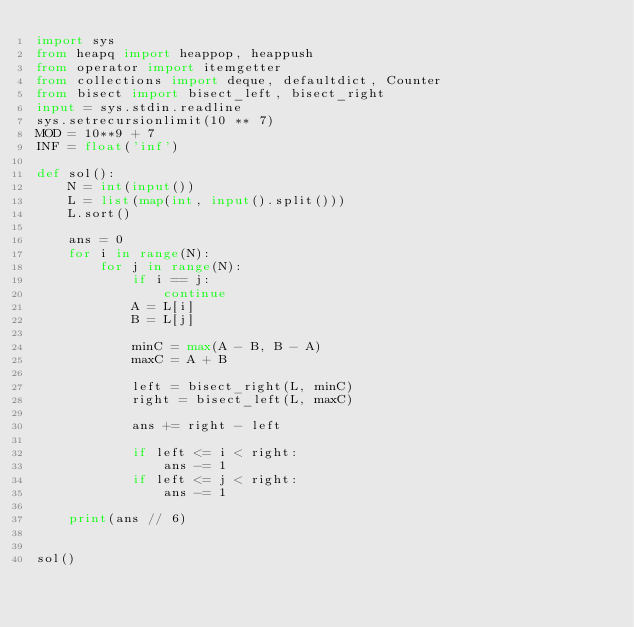<code> <loc_0><loc_0><loc_500><loc_500><_Python_>import sys
from heapq import heappop, heappush
from operator import itemgetter
from collections import deque, defaultdict, Counter
from bisect import bisect_left, bisect_right
input = sys.stdin.readline
sys.setrecursionlimit(10 ** 7)
MOD = 10**9 + 7
INF = float('inf')

def sol():
    N = int(input())
    L = list(map(int, input().split()))
    L.sort()

    ans = 0
    for i in range(N):
        for j in range(N):
            if i == j:
                continue
            A = L[i]
            B = L[j]

            minC = max(A - B, B - A)
            maxC = A + B

            left = bisect_right(L, minC)
            right = bisect_left(L, maxC)

            ans += right - left

            if left <= i < right:
                ans -= 1
            if left <= j < right:
                ans -= 1

    print(ans // 6)


sol()</code> 